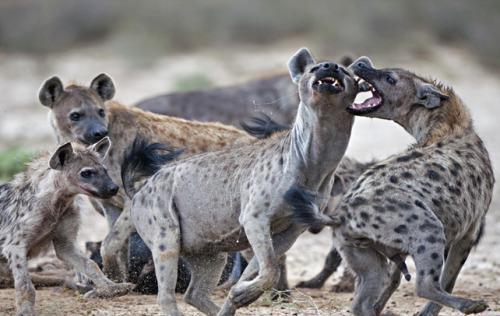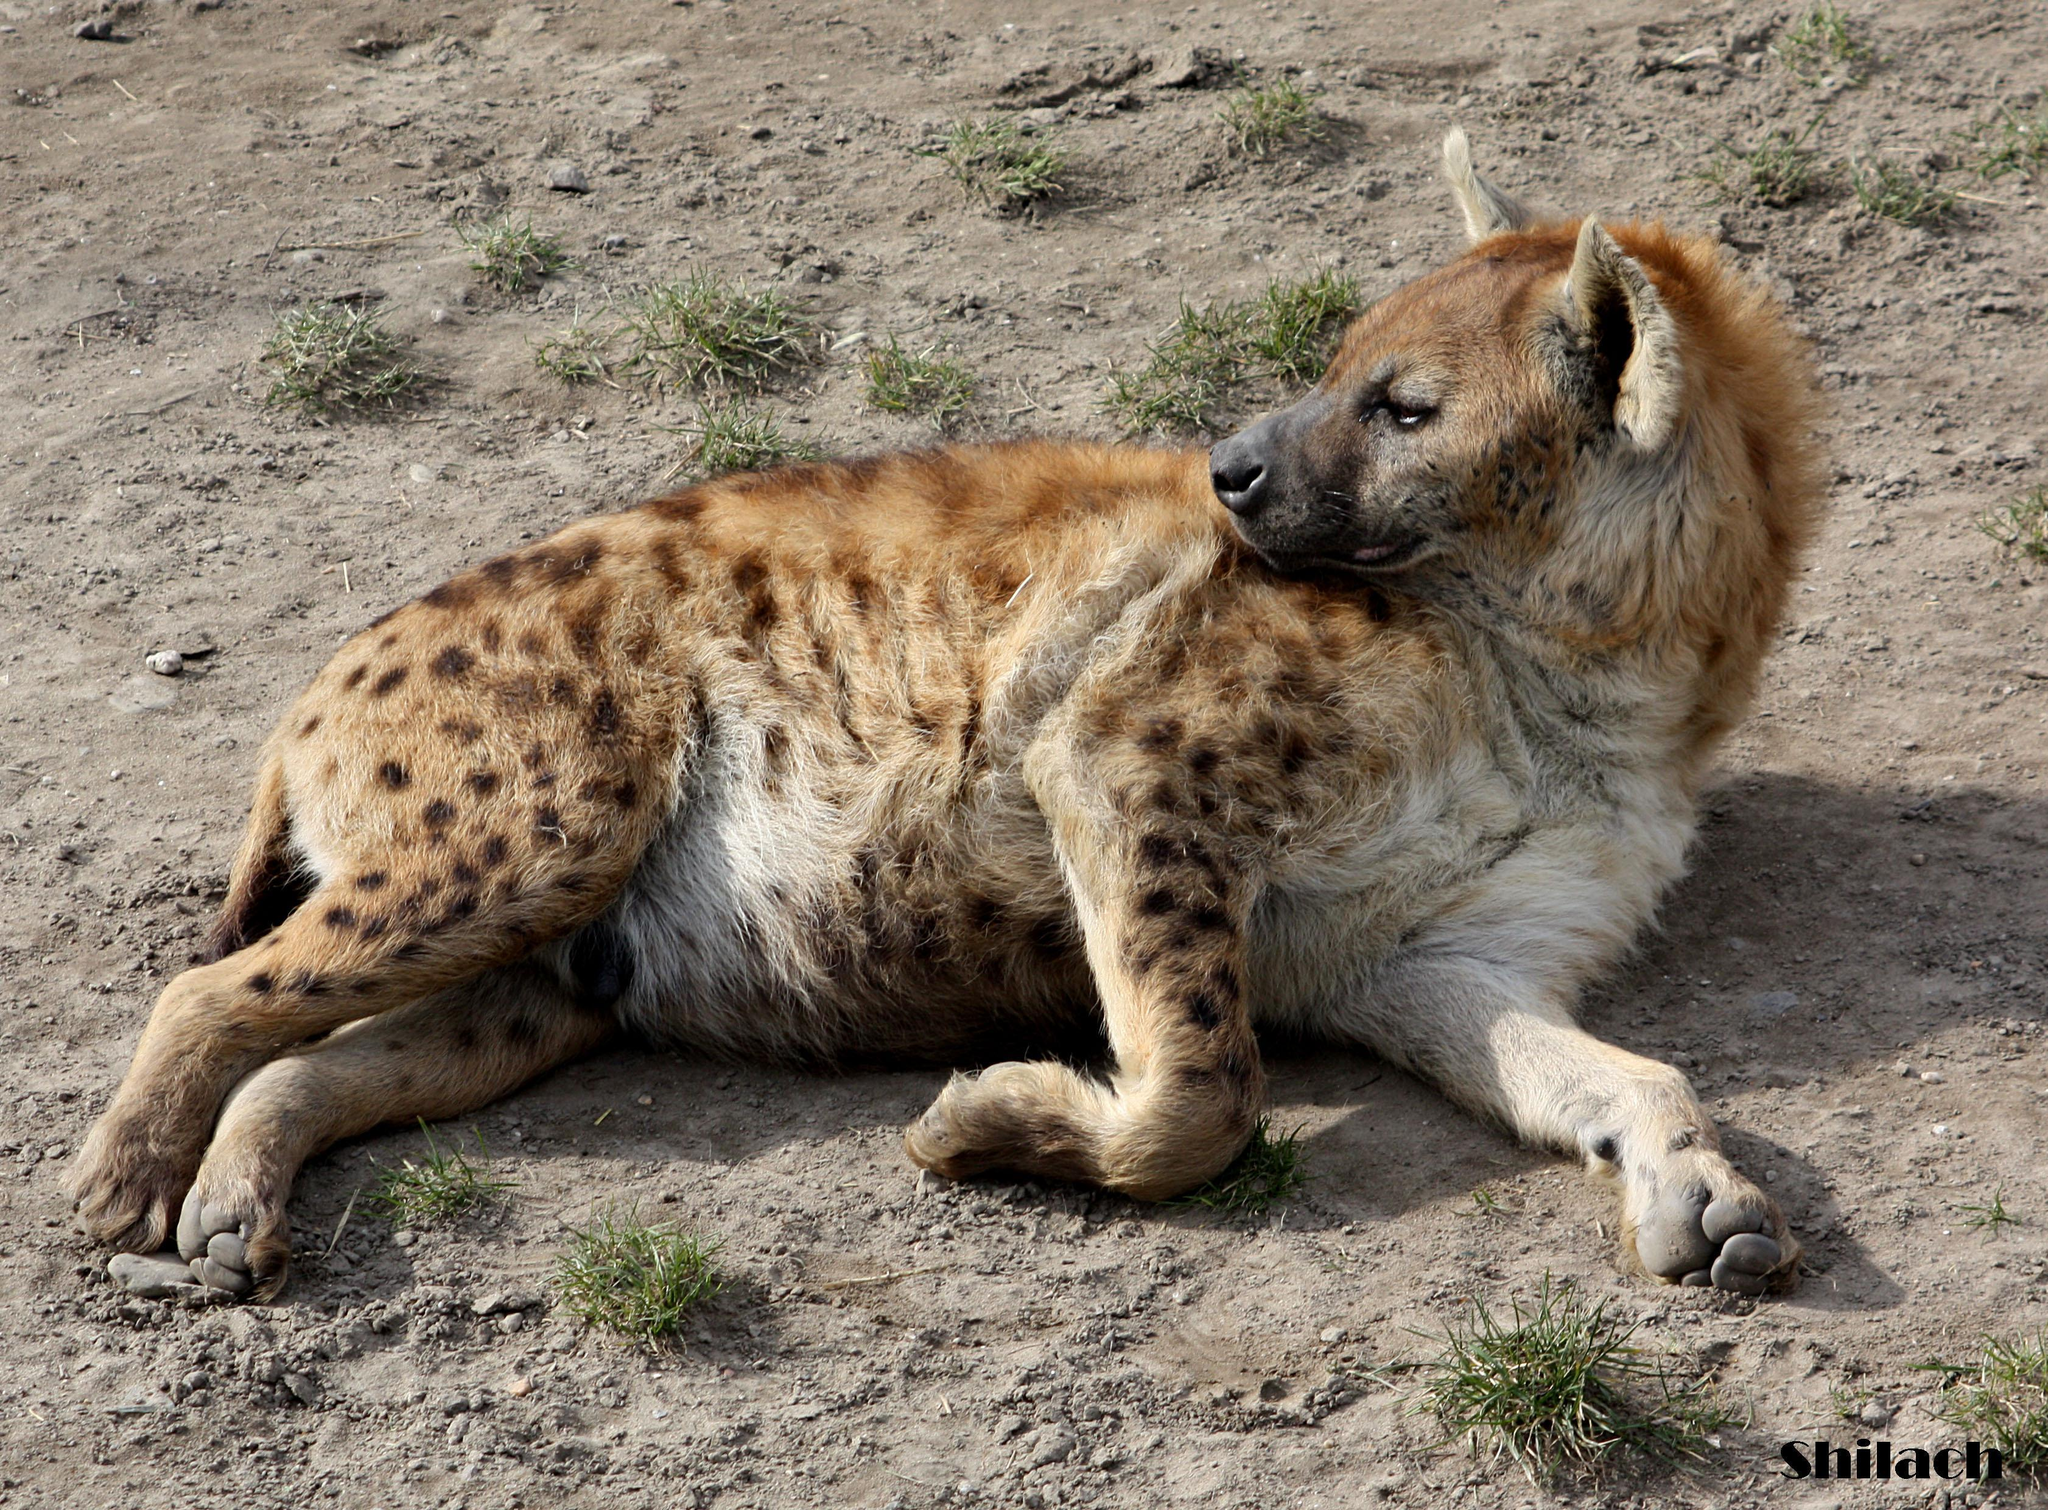The first image is the image on the left, the second image is the image on the right. Examine the images to the left and right. Is the description "An image shows a closely grouped trio of hyenas looking at the camera, all with closed mouths." accurate? Answer yes or no. No. 